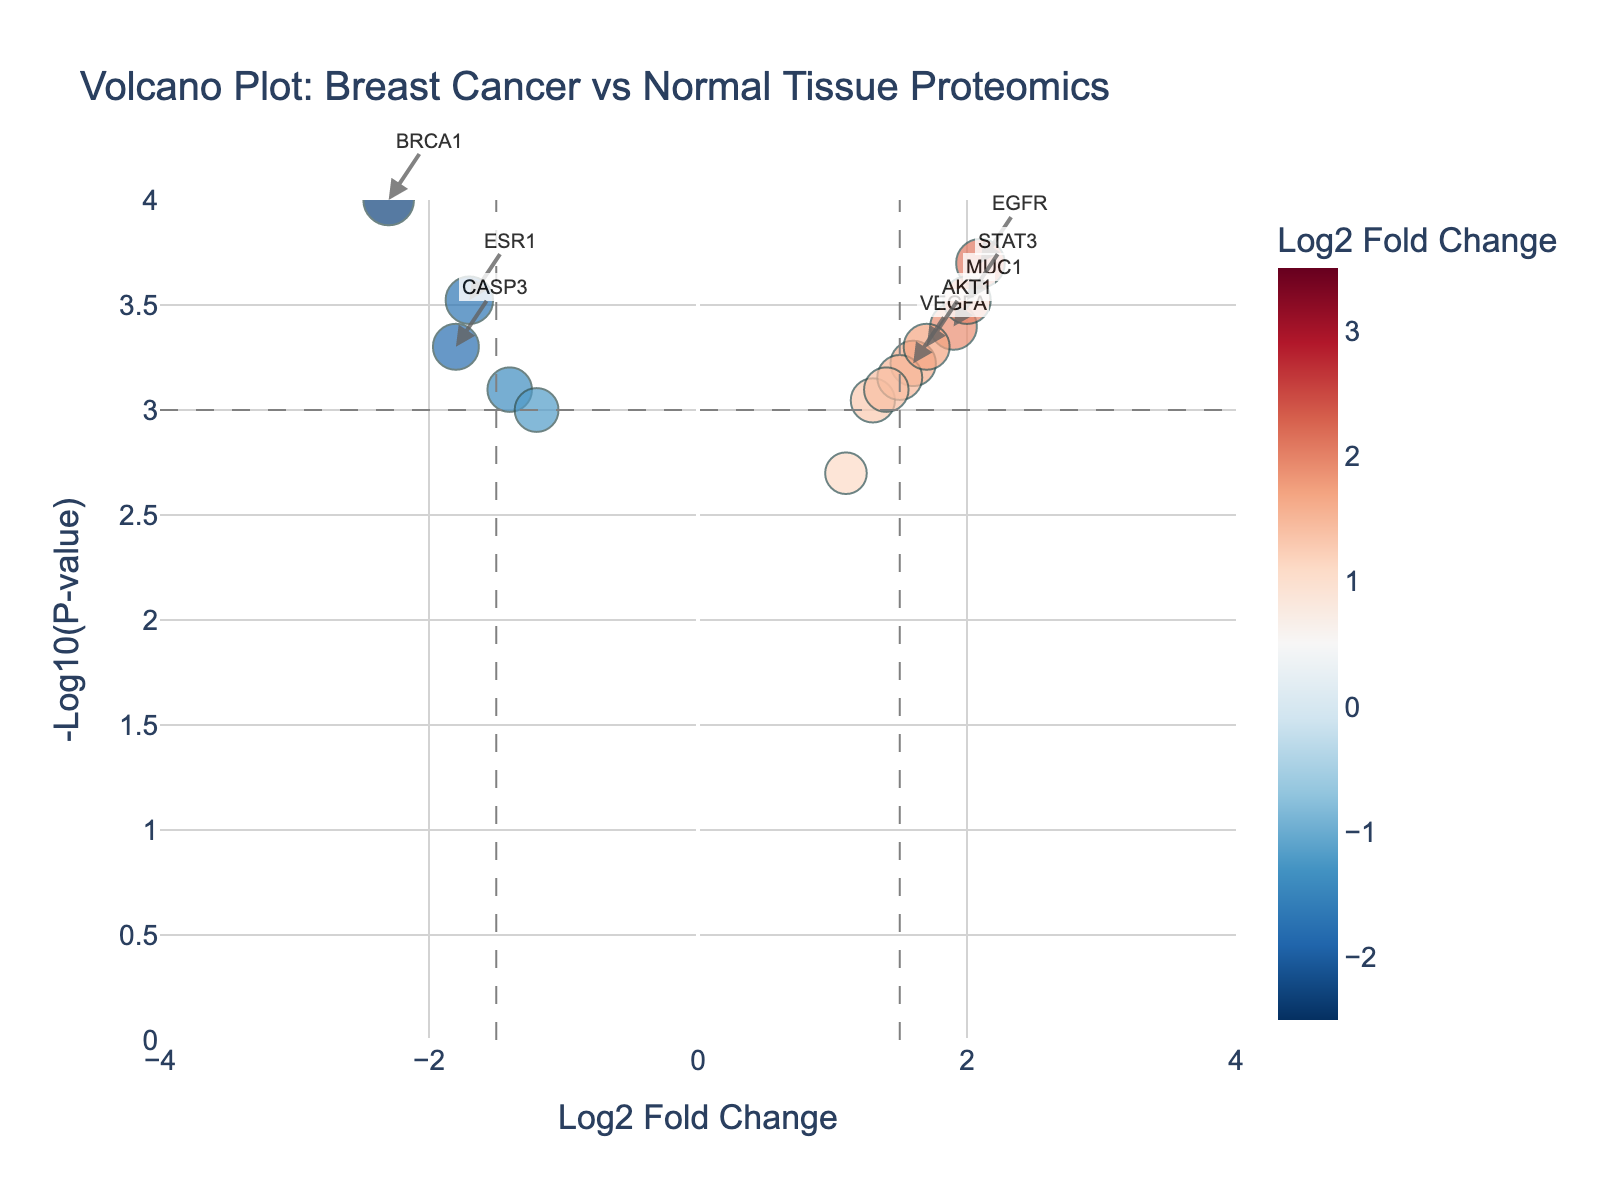Which protein has the highest log2 fold change? Identify the highest point along the x-axis representing the log2 fold change.
Answer: HER2 Which protein has the lowest P-value? The lowest P-value corresponds to the highest point along the y-axis, representing -log10(P-value).
Answer: TP53 How many proteins have a log2 fold change greater than 2? Count the data points that are positioned to the right of the x = 2 line on the plot.
Answer: Three proteins (HER2, CCND1, and ERBB2) Which protein has the most significant downregulation? Look for the protein with the most negative log2 fold change and also check its P-value.
Answer: PTEN Which proteins are within the significance thresholds for log2 fold change and P-value? Proteins outside the thresholds will be beyond x = ±1.5 and above y = -log10(0.001). Count those data points.
Answer: Seven proteins (BRCA1, TP53, HER2, EGFR, PTEN, CCND1, MMP9) What is the log2 fold change and P-value for the protein ESR1? Locate the protein labeled ESR1 and check its coordinates on the plot.
Answer: Log2 fold change: -1.7, P-value: 0.0003 What can you infer about the expression of BRCA1 in cancer tissue compared to normal tissue? Determine whether the log2 fold change for BRCA1 is positive or negative and consider the magnitude and significance of its P-value.
Answer: BRCA1 is significantly downregulated in cancer tissue (log2 fold change: -2.3, P-value: 0.0001) Compare the log2 fold change values of EGFR and MUC1. Which is higher? Find the data points for EGFR and MUC1 and compare their log2 fold change values.
Answer: EGFR (log2 fold change: 2.1) is higher than MUC1 (log2 fold change: 1.9) How many proteins have a P-value greater than 0.001? Count the data points below the significance threshold line at y = -log10(0.001).
Answer: Six proteins (CDH1, VEGFA, BAX, BCL2, CASP3, TNF) Which proteins are annotated in the plot? Identify the proteins that are labeled with text in the plot, indicating significant change and low P-value.
Answer: BRCA1, TP53, HER2, EGFR, PTEN, CCND1, MMP9, ERBB2 